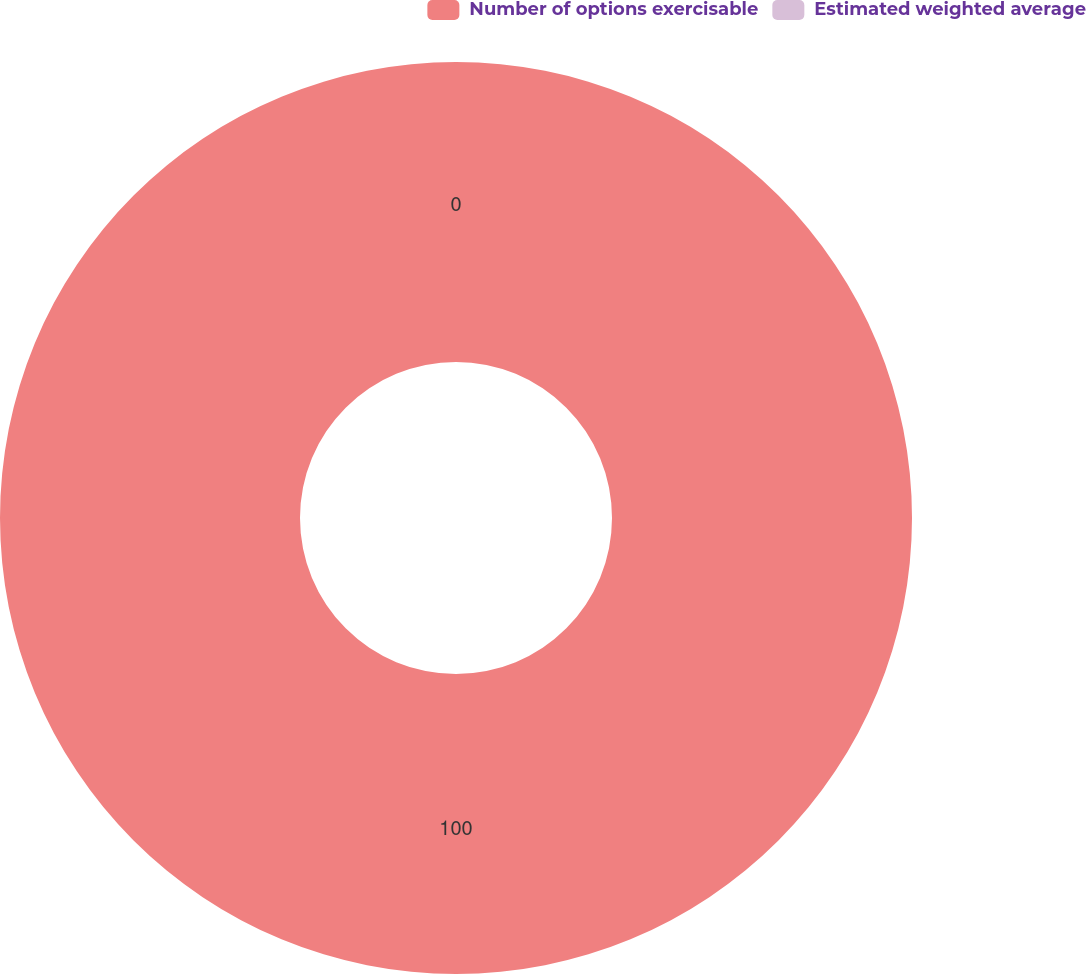Convert chart. <chart><loc_0><loc_0><loc_500><loc_500><pie_chart><fcel>Number of options exercisable<fcel>Estimated weighted average<nl><fcel>100.0%<fcel>0.0%<nl></chart> 